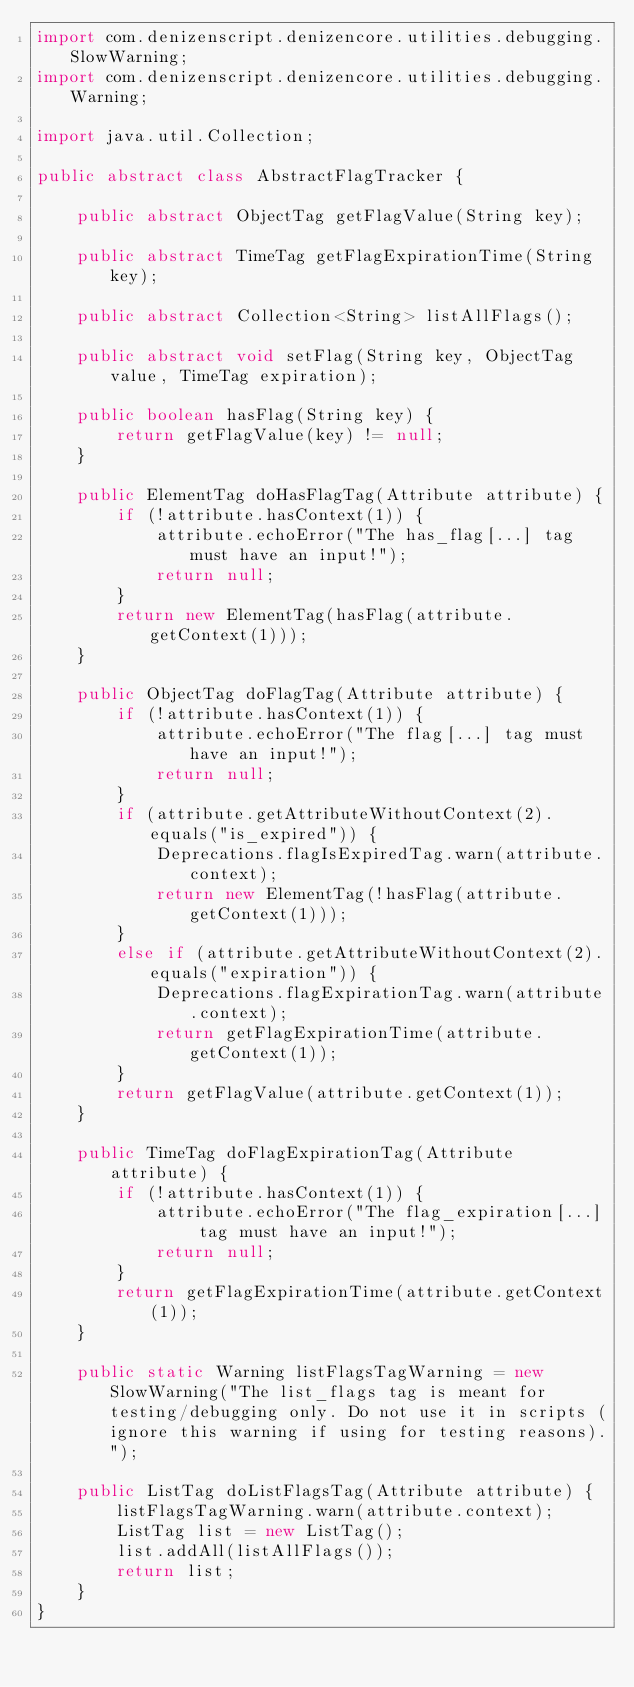Convert code to text. <code><loc_0><loc_0><loc_500><loc_500><_Java_>import com.denizenscript.denizencore.utilities.debugging.SlowWarning;
import com.denizenscript.denizencore.utilities.debugging.Warning;

import java.util.Collection;

public abstract class AbstractFlagTracker {

    public abstract ObjectTag getFlagValue(String key);

    public abstract TimeTag getFlagExpirationTime(String key);

    public abstract Collection<String> listAllFlags();

    public abstract void setFlag(String key, ObjectTag value, TimeTag expiration);

    public boolean hasFlag(String key) {
        return getFlagValue(key) != null;
    }

    public ElementTag doHasFlagTag(Attribute attribute) {
        if (!attribute.hasContext(1)) {
            attribute.echoError("The has_flag[...] tag must have an input!");
            return null;
        }
        return new ElementTag(hasFlag(attribute.getContext(1)));
    }

    public ObjectTag doFlagTag(Attribute attribute) {
        if (!attribute.hasContext(1)) {
            attribute.echoError("The flag[...] tag must have an input!");
            return null;
        }
        if (attribute.getAttributeWithoutContext(2).equals("is_expired")) {
            Deprecations.flagIsExpiredTag.warn(attribute.context);
            return new ElementTag(!hasFlag(attribute.getContext(1)));
        }
        else if (attribute.getAttributeWithoutContext(2).equals("expiration")) {
            Deprecations.flagExpirationTag.warn(attribute.context);
            return getFlagExpirationTime(attribute.getContext(1));
        }
        return getFlagValue(attribute.getContext(1));
    }

    public TimeTag doFlagExpirationTag(Attribute attribute) {
        if (!attribute.hasContext(1)) {
            attribute.echoError("The flag_expiration[...] tag must have an input!");
            return null;
        }
        return getFlagExpirationTime(attribute.getContext(1));
    }

    public static Warning listFlagsTagWarning = new SlowWarning("The list_flags tag is meant for testing/debugging only. Do not use it in scripts (ignore this warning if using for testing reasons).");

    public ListTag doListFlagsTag(Attribute attribute) {
        listFlagsTagWarning.warn(attribute.context);
        ListTag list = new ListTag();
        list.addAll(listAllFlags());
        return list;
    }
}
</code> 